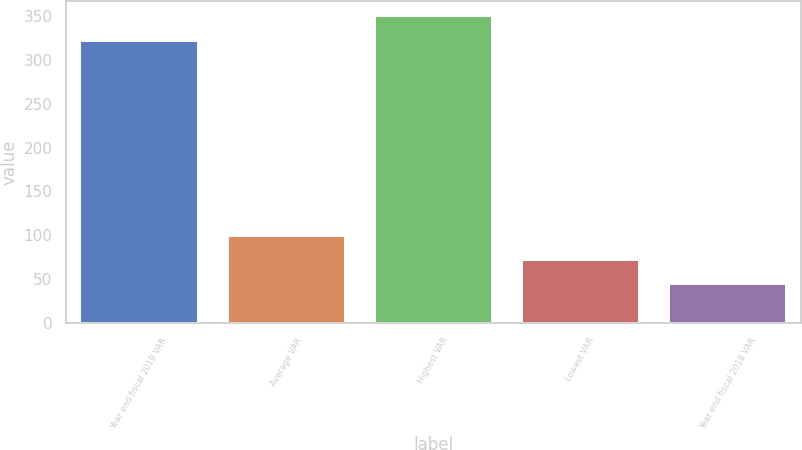Convert chart. <chart><loc_0><loc_0><loc_500><loc_500><bar_chart><fcel>Year end fiscal 2019 VAR<fcel>Average VAR<fcel>Highest VAR<fcel>Lowest VAR<fcel>Year end fiscal 2018 VAR<nl><fcel>322<fcel>99.6<fcel>349.8<fcel>71.8<fcel>44<nl></chart> 